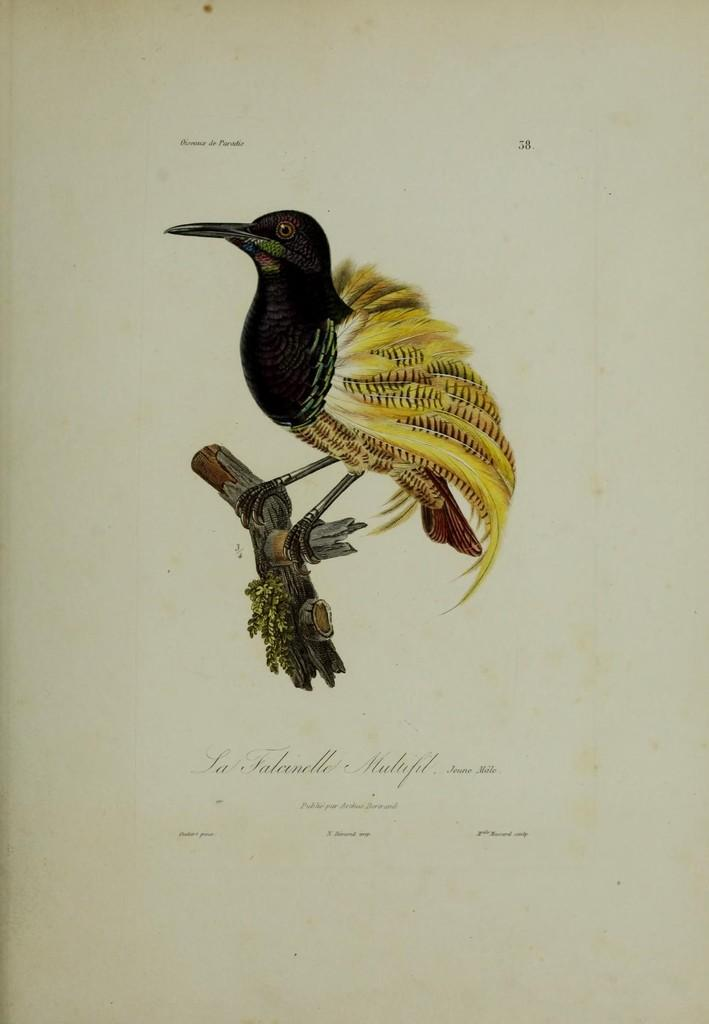What type of animal can be seen in the image? There is a bird in the image. Where is the bird located? The bird is on a branch. Is there any text present in the image? Yes, there is text at the bottom of the image. What type of gold object is visible in the image? There is no gold object present in the image. Can you see a boat in the image? No, there is no boat present in the image. 